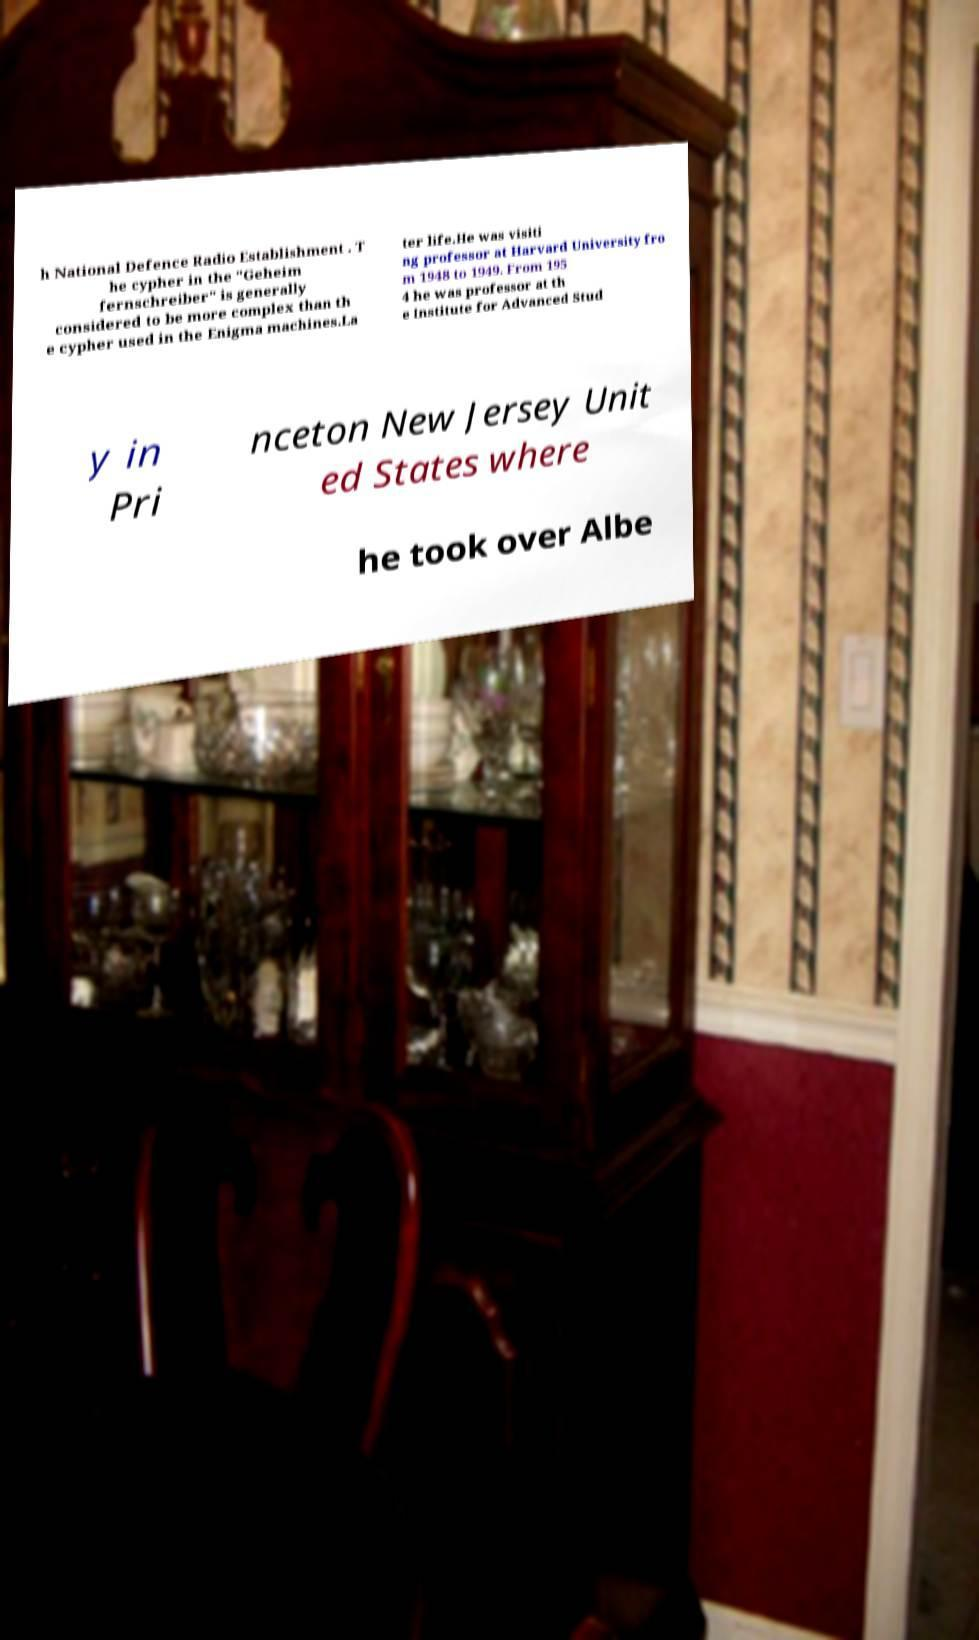Can you read and provide the text displayed in the image?This photo seems to have some interesting text. Can you extract and type it out for me? h National Defence Radio Establishment . T he cypher in the "Geheim fernschreiber" is generally considered to be more complex than th e cypher used in the Enigma machines.La ter life.He was visiti ng professor at Harvard University fro m 1948 to 1949. From 195 4 he was professor at th e Institute for Advanced Stud y in Pri nceton New Jersey Unit ed States where he took over Albe 